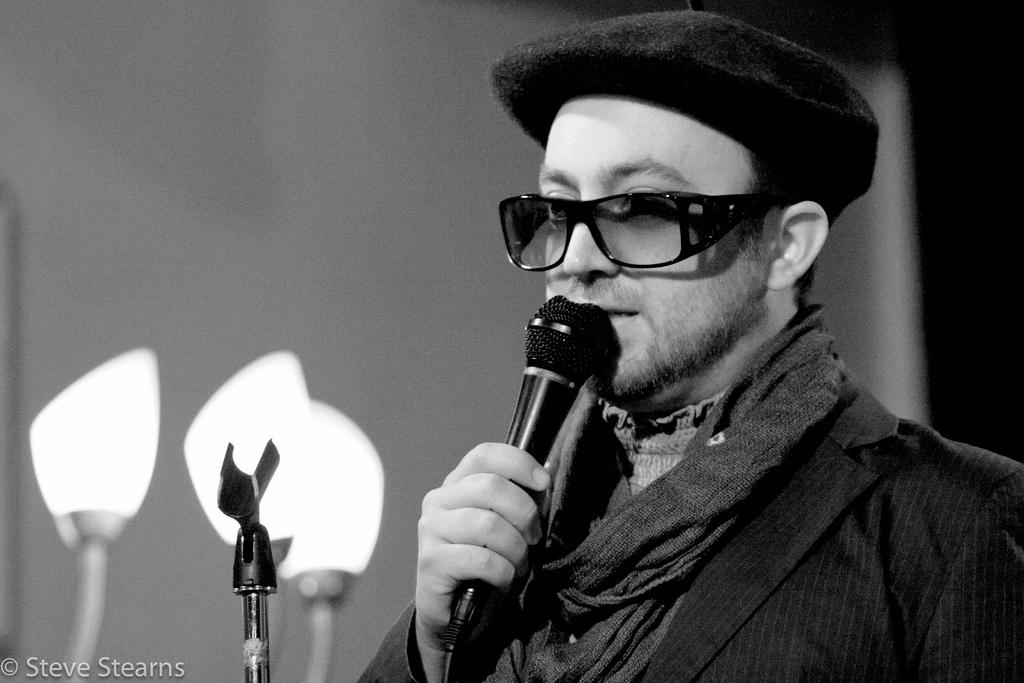What is the main subject of the image? The main subject of the image is a man. What is the man wearing on his head? The man is wearing a cap. What is the man wearing on his upper body? The man is wearing a blazer. What is the man wearing around his neck? The man is wearing a scarf. What is the man wearing to protect his eyes? The man is wearing goggles. What is the man holding in his hand? The man is holding a mic in his hand. What is the man doing in the image? The man is talking. What can be seen in the image? There are lights and a stand in the image. What is the background of the image? There is a wall in the image. What type of lawyer is the man representing in the image? There is no indication in the image that the man is a lawyer or representing anyone. 